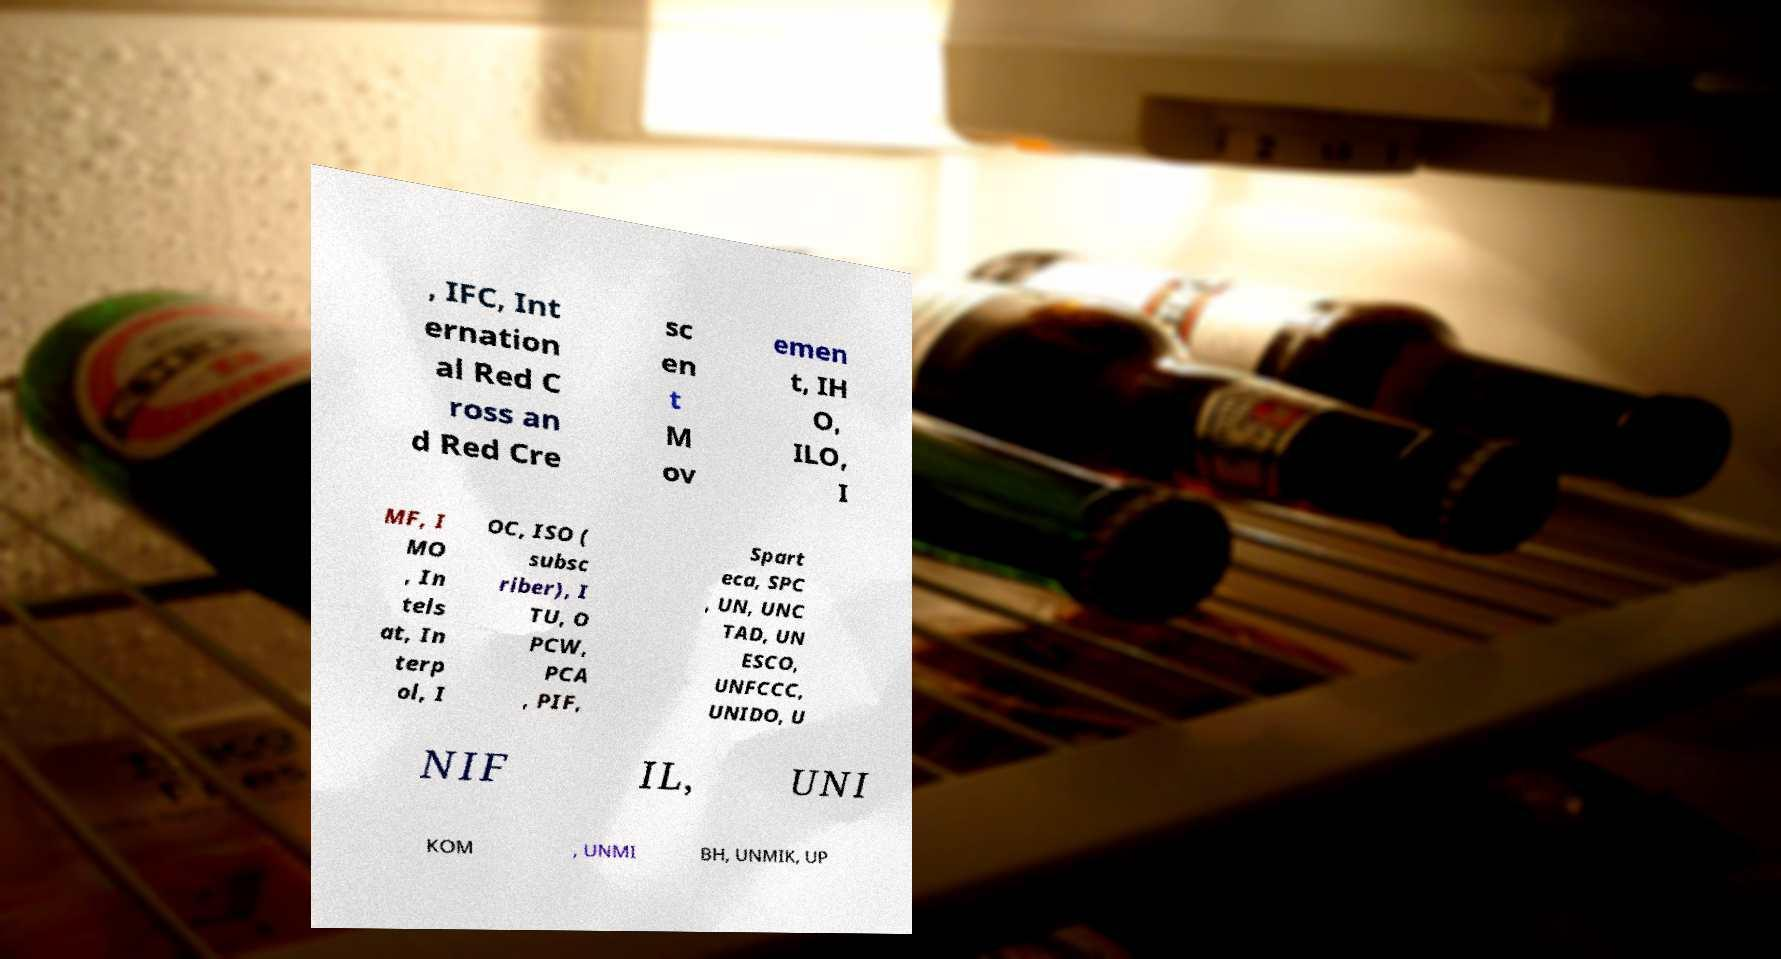There's text embedded in this image that I need extracted. Can you transcribe it verbatim? , IFC, Int ernation al Red C ross an d Red Cre sc en t M ov emen t, IH O, ILO, I MF, I MO , In tels at, In terp ol, I OC, ISO ( subsc riber), I TU, O PCW, PCA , PIF, Spart eca, SPC , UN, UNC TAD, UN ESCO, UNFCCC, UNIDO, U NIF IL, UNI KOM , UNMI BH, UNMIK, UP 